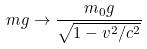<formula> <loc_0><loc_0><loc_500><loc_500>m g \rightarrow \frac { m _ { 0 } g } { \sqrt { 1 - v ^ { 2 } / c ^ { 2 } } }</formula> 